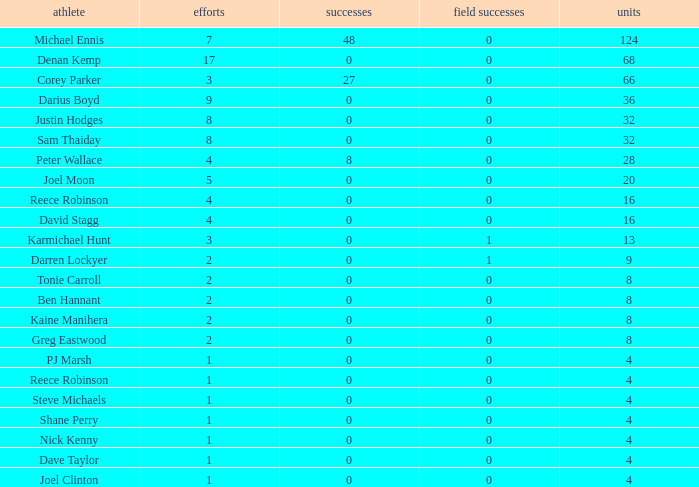What is the number of goals Dave Taylor, who has more than 1 tries, has? None. 